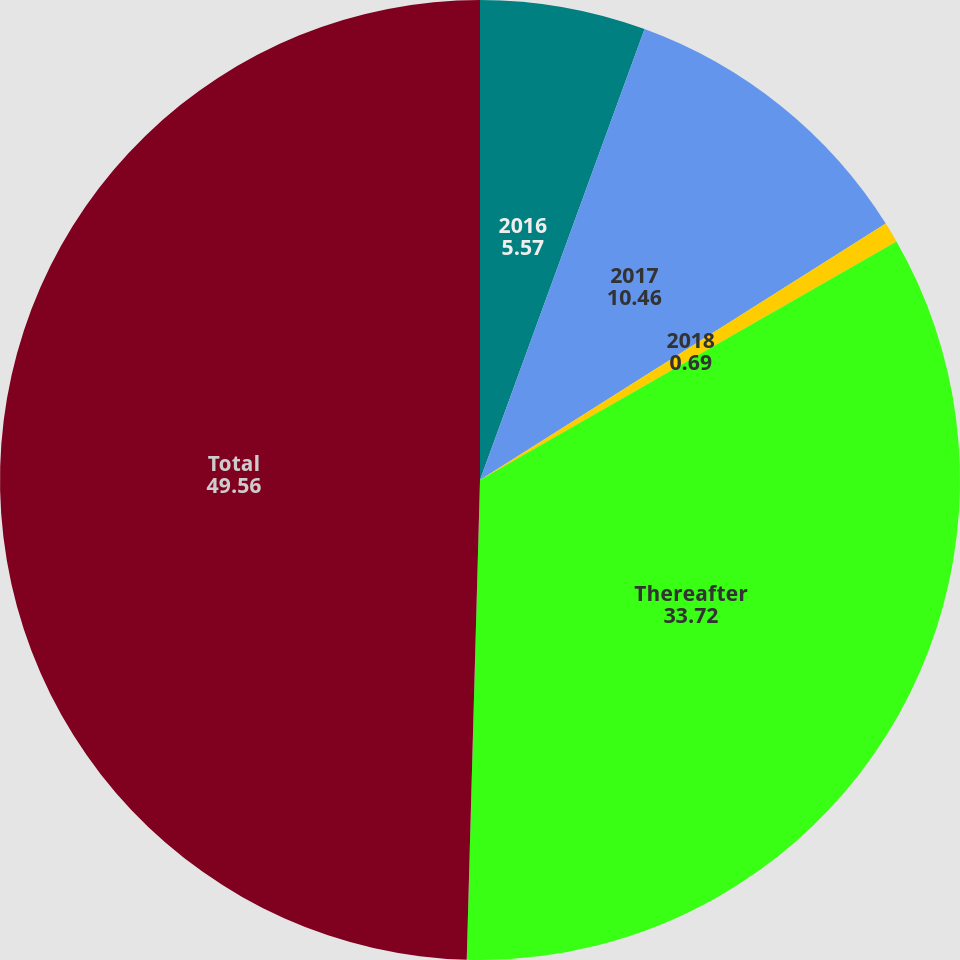Convert chart. <chart><loc_0><loc_0><loc_500><loc_500><pie_chart><fcel>2016<fcel>2017<fcel>2018<fcel>Thereafter<fcel>Total<nl><fcel>5.57%<fcel>10.46%<fcel>0.69%<fcel>33.72%<fcel>49.56%<nl></chart> 